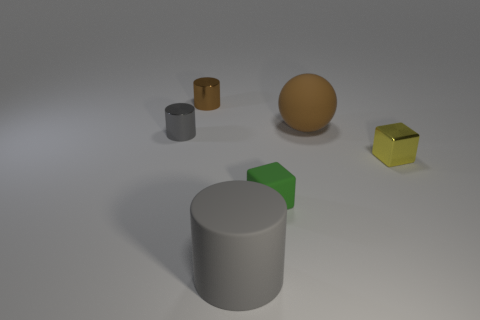Add 3 green matte blocks. How many objects exist? 9 Subtract all balls. How many objects are left? 5 Add 1 small brown objects. How many small brown objects are left? 2 Add 4 blocks. How many blocks exist? 6 Subtract 1 brown cylinders. How many objects are left? 5 Subtract all red metallic cubes. Subtract all gray matte things. How many objects are left? 5 